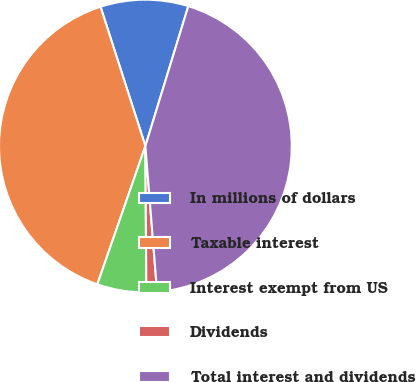Convert chart. <chart><loc_0><loc_0><loc_500><loc_500><pie_chart><fcel>In millions of dollars<fcel>Taxable interest<fcel>Interest exempt from US<fcel>Dividends<fcel>Total interest and dividends<nl><fcel>9.7%<fcel>39.72%<fcel>5.43%<fcel>1.17%<fcel>43.99%<nl></chart> 